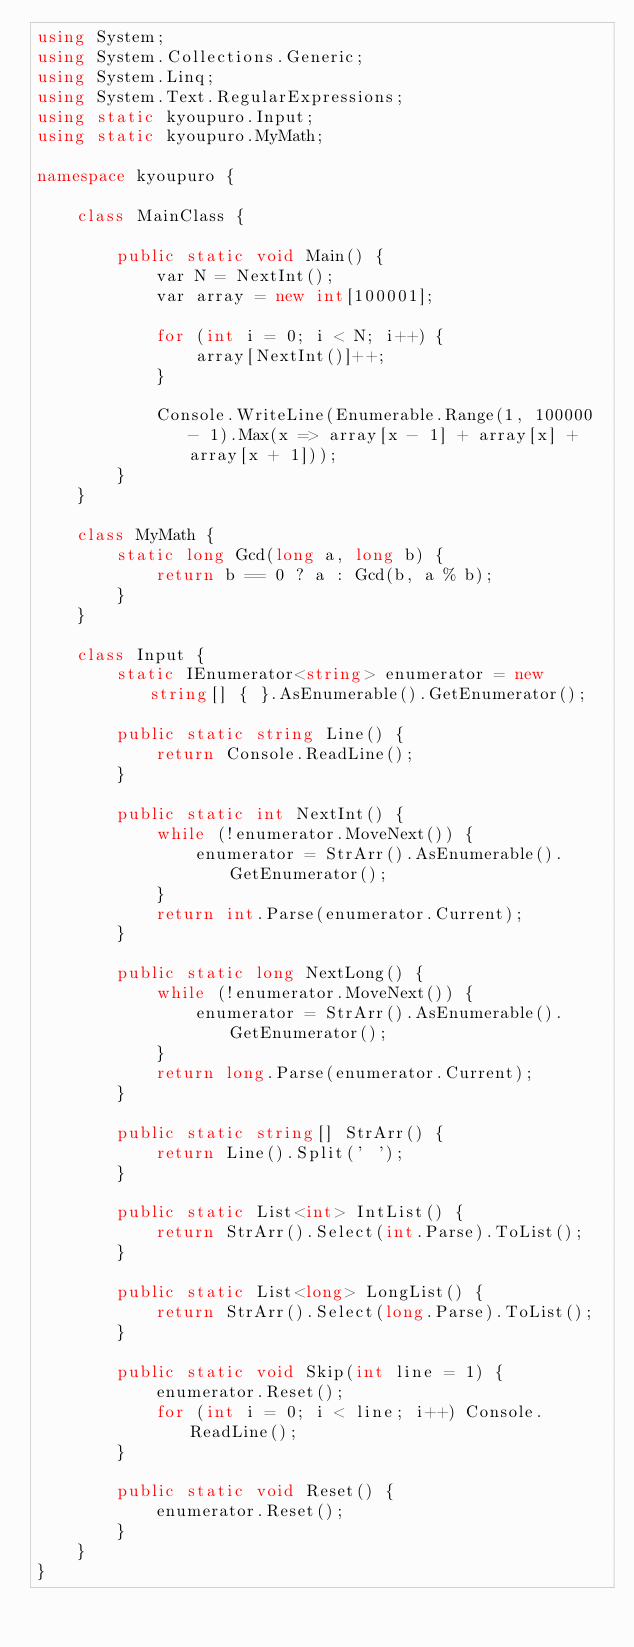<code> <loc_0><loc_0><loc_500><loc_500><_C#_>using System;
using System.Collections.Generic;
using System.Linq;
using System.Text.RegularExpressions;
using static kyoupuro.Input;
using static kyoupuro.MyMath;

namespace kyoupuro {

    class MainClass {

        public static void Main() {
            var N = NextInt();
            var array = new int[100001];

            for (int i = 0; i < N; i++) {
                array[NextInt()]++;
            }

            Console.WriteLine(Enumerable.Range(1, 100000 - 1).Max(x => array[x - 1] + array[x] + array[x + 1]));
        }
    }

    class MyMath {
        static long Gcd(long a, long b) {
            return b == 0 ? a : Gcd(b, a % b);
        }
    }

    class Input {
        static IEnumerator<string> enumerator = new string[] { }.AsEnumerable().GetEnumerator();

        public static string Line() {
            return Console.ReadLine();
        }

        public static int NextInt() {
            while (!enumerator.MoveNext()) {
                enumerator = StrArr().AsEnumerable().GetEnumerator();
            }
            return int.Parse(enumerator.Current);
        }

        public static long NextLong() {
            while (!enumerator.MoveNext()) {
                enumerator = StrArr().AsEnumerable().GetEnumerator();
            }
            return long.Parse(enumerator.Current);
        }

        public static string[] StrArr() {
            return Line().Split(' ');
        }

        public static List<int> IntList() {
            return StrArr().Select(int.Parse).ToList();
        }

        public static List<long> LongList() {
            return StrArr().Select(long.Parse).ToList();
        }

        public static void Skip(int line = 1) {
            enumerator.Reset();
            for (int i = 0; i < line; i++) Console.ReadLine();
        }

        public static void Reset() {
            enumerator.Reset();
        }
    }
}</code> 